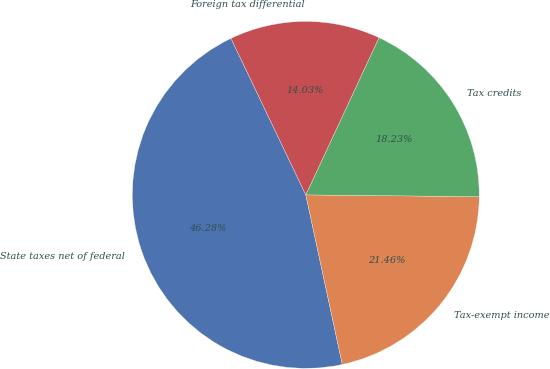Convert chart to OTSL. <chart><loc_0><loc_0><loc_500><loc_500><pie_chart><fcel>State taxes net of federal<fcel>Tax-exempt income<fcel>Tax credits<fcel>Foreign tax differential<nl><fcel>46.28%<fcel>21.46%<fcel>18.23%<fcel>14.03%<nl></chart> 